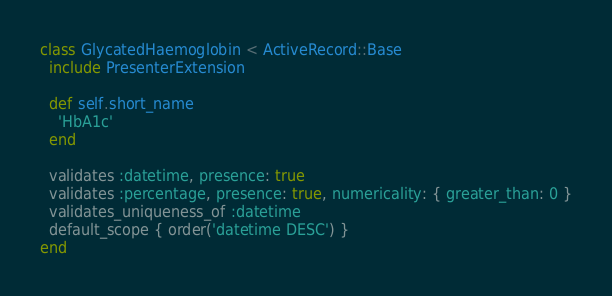<code> <loc_0><loc_0><loc_500><loc_500><_Ruby_>class GlycatedHaemoglobin < ActiveRecord::Base
  include PresenterExtension

  def self.short_name
    'HbA1c'
  end

  validates :datetime, presence: true
  validates :percentage, presence: true, numericality: { greater_than: 0 }
  validates_uniqueness_of :datetime
  default_scope { order('datetime DESC') }
end
</code> 